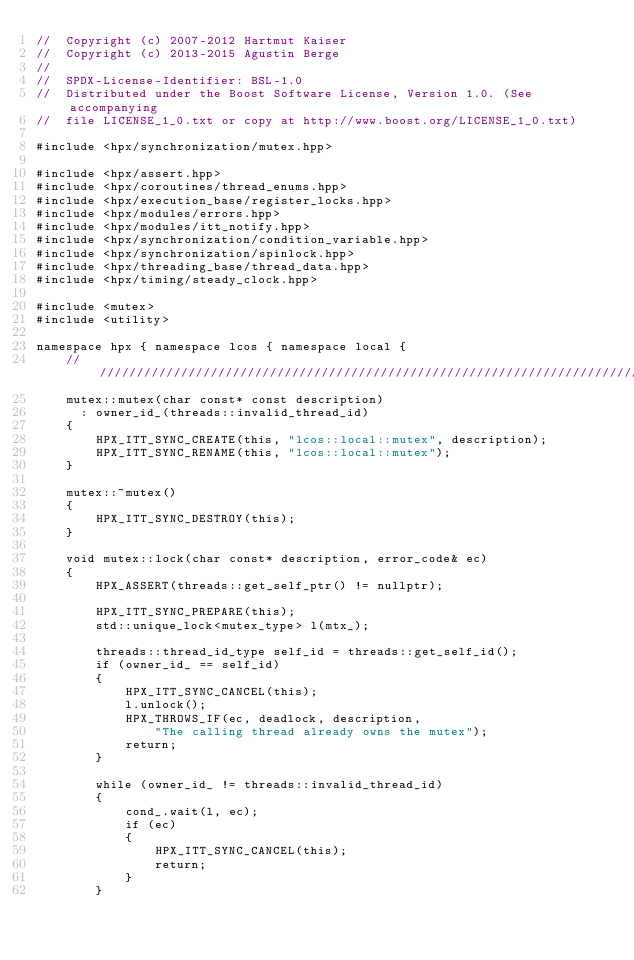Convert code to text. <code><loc_0><loc_0><loc_500><loc_500><_C++_>//  Copyright (c) 2007-2012 Hartmut Kaiser
//  Copyright (c) 2013-2015 Agustin Berge
//
//  SPDX-License-Identifier: BSL-1.0
//  Distributed under the Boost Software License, Version 1.0. (See accompanying
//  file LICENSE_1_0.txt or copy at http://www.boost.org/LICENSE_1_0.txt)

#include <hpx/synchronization/mutex.hpp>

#include <hpx/assert.hpp>
#include <hpx/coroutines/thread_enums.hpp>
#include <hpx/execution_base/register_locks.hpp>
#include <hpx/modules/errors.hpp>
#include <hpx/modules/itt_notify.hpp>
#include <hpx/synchronization/condition_variable.hpp>
#include <hpx/synchronization/spinlock.hpp>
#include <hpx/threading_base/thread_data.hpp>
#include <hpx/timing/steady_clock.hpp>

#include <mutex>
#include <utility>

namespace hpx { namespace lcos { namespace local {
    ///////////////////////////////////////////////////////////////////////////
    mutex::mutex(char const* const description)
      : owner_id_(threads::invalid_thread_id)
    {
        HPX_ITT_SYNC_CREATE(this, "lcos::local::mutex", description);
        HPX_ITT_SYNC_RENAME(this, "lcos::local::mutex");
    }

    mutex::~mutex()
    {
        HPX_ITT_SYNC_DESTROY(this);
    }

    void mutex::lock(char const* description, error_code& ec)
    {
        HPX_ASSERT(threads::get_self_ptr() != nullptr);

        HPX_ITT_SYNC_PREPARE(this);
        std::unique_lock<mutex_type> l(mtx_);

        threads::thread_id_type self_id = threads::get_self_id();
        if (owner_id_ == self_id)
        {
            HPX_ITT_SYNC_CANCEL(this);
            l.unlock();
            HPX_THROWS_IF(ec, deadlock, description,
                "The calling thread already owns the mutex");
            return;
        }

        while (owner_id_ != threads::invalid_thread_id)
        {
            cond_.wait(l, ec);
            if (ec)
            {
                HPX_ITT_SYNC_CANCEL(this);
                return;
            }
        }
</code> 